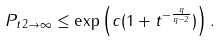<formula> <loc_0><loc_0><loc_500><loc_500>\| P _ { t } \| _ { 2 \rightarrow \infty } \leq \exp \left ( c ( 1 + t ^ { - \frac { q } { q - 2 } } ) \right ) .</formula> 